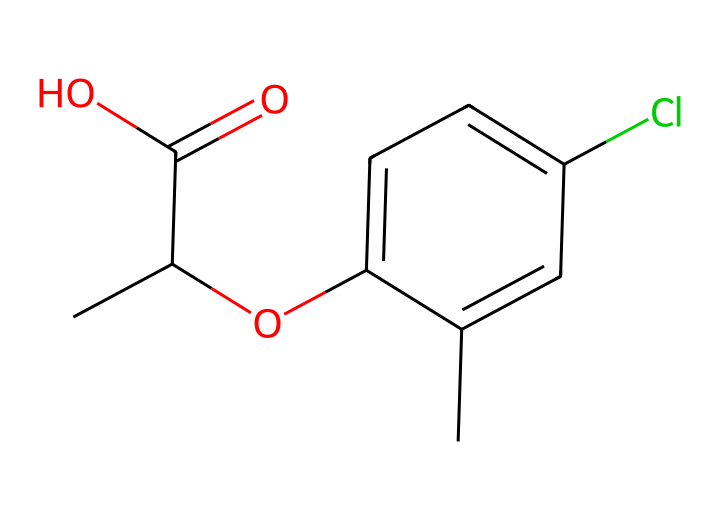What is the molecular formula of mecoprop? The SMILES representation can be translated to a molecular formula by counting the atoms present: there are 12 carbon atoms, 13 hydrogen atoms, 3 oxygen atoms, and 1 chlorine atom, resulting in a formula of C12H13ClO3.
Answer: C12H13ClO3 How many carbon atoms are present in mecoprop? By examining the SMILES representation, one can count the 'C' entries, which indicate the number of carbon atoms. There are 12 instances of 'C' in the SMILES representation.
Answer: 12 What functional group is characteristic of mecoprop's structure? The presence of the carboxylic acid group (–COOH) is indicated by the presence of a carbon atom double-bonded to an oxygen atom and single-bonded to a hydroxyl group (O). This functional group defines its acidic property.
Answer: carboxylic acid What does the Cl in the structure of mecoprop signify? The 'Cl' in the SMILES structure represents a chlorine atom, which is a halogen. Its presence suggests the compound may have properties such as increased herbicidal activity due to the electronegativity of chlorine.
Answer: chlorine Why is mecoprop classified as a herbicide? Mecoprop's structure includes several features typical of herbicides, such as the ability to disrupt plant growth hormones (auxins), which is indicated by its specific molecular arrangement and functional groups, particularly the carboxylic acid.
Answer: disruption of plant hormones In what environments is mecoprop typically found? Mecoprop is commonly used in urban areas, parks, and turf management, as indicated by its intended use as a herbicide for controlling unwanted vegetation in such settings.
Answer: urban areas What is the main purpose of the ester group in mecoprop's structure? The ester group is indicated by the 'O' connected to both a carbon atom and another part of the molecule, suggesting that it may aid in solubility and mobility within the target plants, making it effective as a herbicide.
Answer: solubility and mobility 